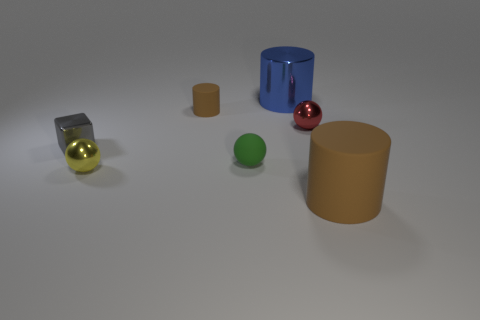There is a yellow metallic thing that is the same shape as the red thing; what is its size?
Offer a very short reply. Small. How many other small objects have the same material as the tiny yellow object?
Provide a succinct answer. 2. What is the material of the small yellow sphere?
Offer a terse response. Metal. There is a brown matte object that is behind the brown object that is in front of the red metallic object; what shape is it?
Provide a short and direct response. Cylinder. There is a brown thing that is to the left of the large brown rubber cylinder; what shape is it?
Give a very brief answer. Cylinder. What number of large rubber things have the same color as the tiny cylinder?
Your answer should be compact. 1. What is the color of the small block?
Give a very brief answer. Gray. There is a matte cylinder that is behind the tiny metal block; how many tiny brown things are behind it?
Give a very brief answer. 0. There is a green object; is its size the same as the rubber thing to the right of the big blue metal object?
Offer a terse response. No. Is the size of the yellow ball the same as the shiny cylinder?
Give a very brief answer. No. 